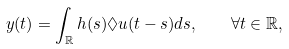<formula> <loc_0><loc_0><loc_500><loc_500>y ( t ) = \int _ { \mathbb { R } } h ( s ) \lozenge u ( t - s ) d s , \quad \forall t \in { \mathbb { R } } ,</formula> 